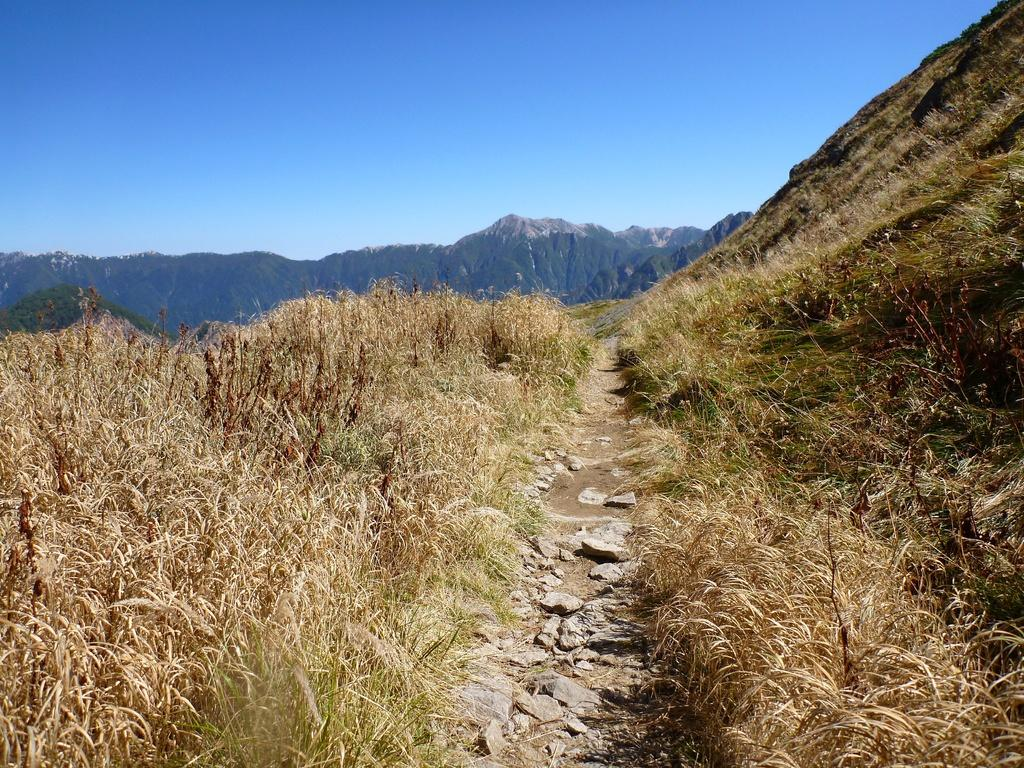What type of vegetation can be seen in the image? There are small plants in the image. What can be found between the plants? There is a path between the plants. What geographical feature is on the right side of the image? There is a hill on the right side of the image. What is visible in the distance in the image? There are mountains visible in the background of the image. What type of fruit is being sold at the zoo in the image? There is no zoo or fruit present in the image; it features small plants, a path, a hill, and mountains in the background. 